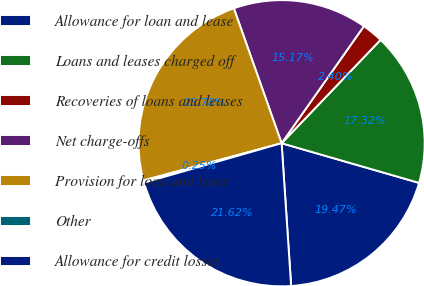Convert chart to OTSL. <chart><loc_0><loc_0><loc_500><loc_500><pie_chart><fcel>Allowance for loan and lease<fcel>Loans and leases charged off<fcel>Recoveries of loans and leases<fcel>Net charge-offs<fcel>Provision for loan and lease<fcel>Other<fcel>Allowance for credit losses<nl><fcel>19.47%<fcel>17.32%<fcel>2.4%<fcel>15.17%<fcel>23.78%<fcel>0.25%<fcel>21.62%<nl></chart> 